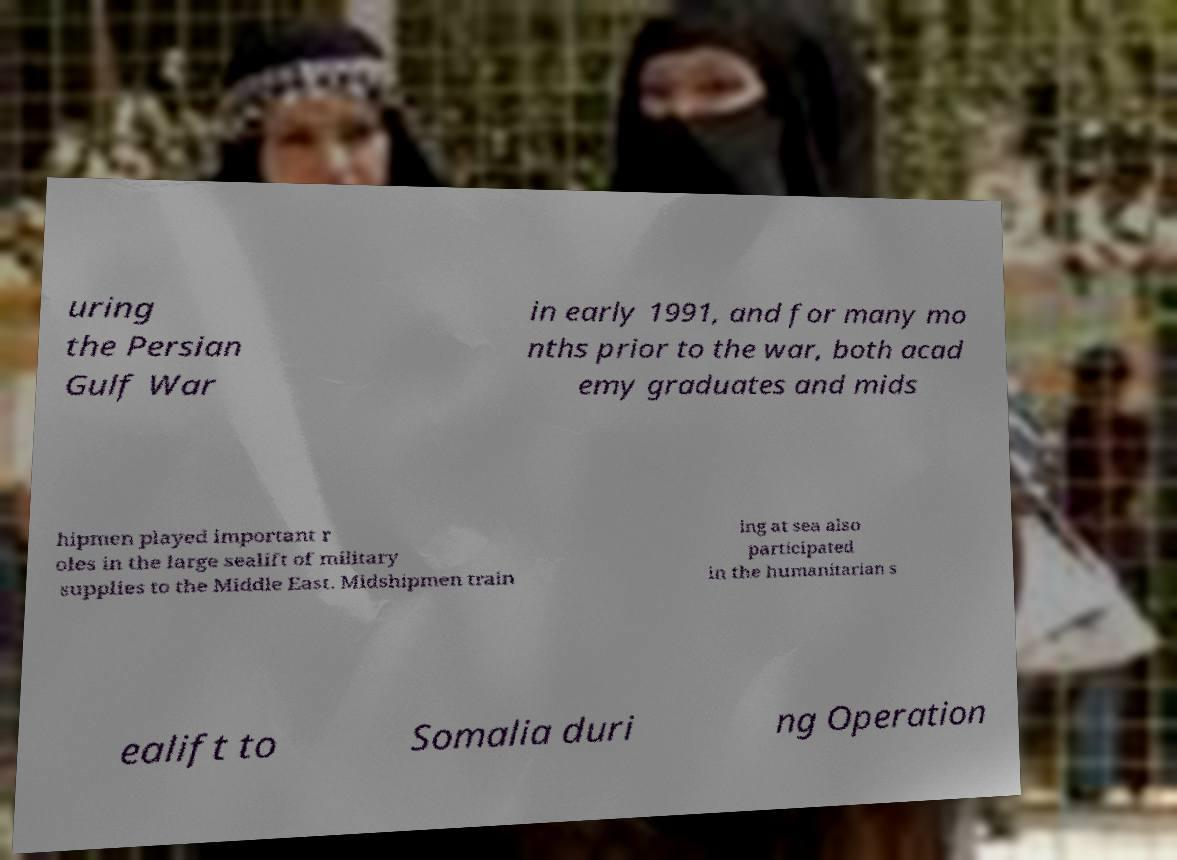What messages or text are displayed in this image? I need them in a readable, typed format. uring the Persian Gulf War in early 1991, and for many mo nths prior to the war, both acad emy graduates and mids hipmen played important r oles in the large sealift of military supplies to the Middle East. Midshipmen train ing at sea also participated in the humanitarian s ealift to Somalia duri ng Operation 